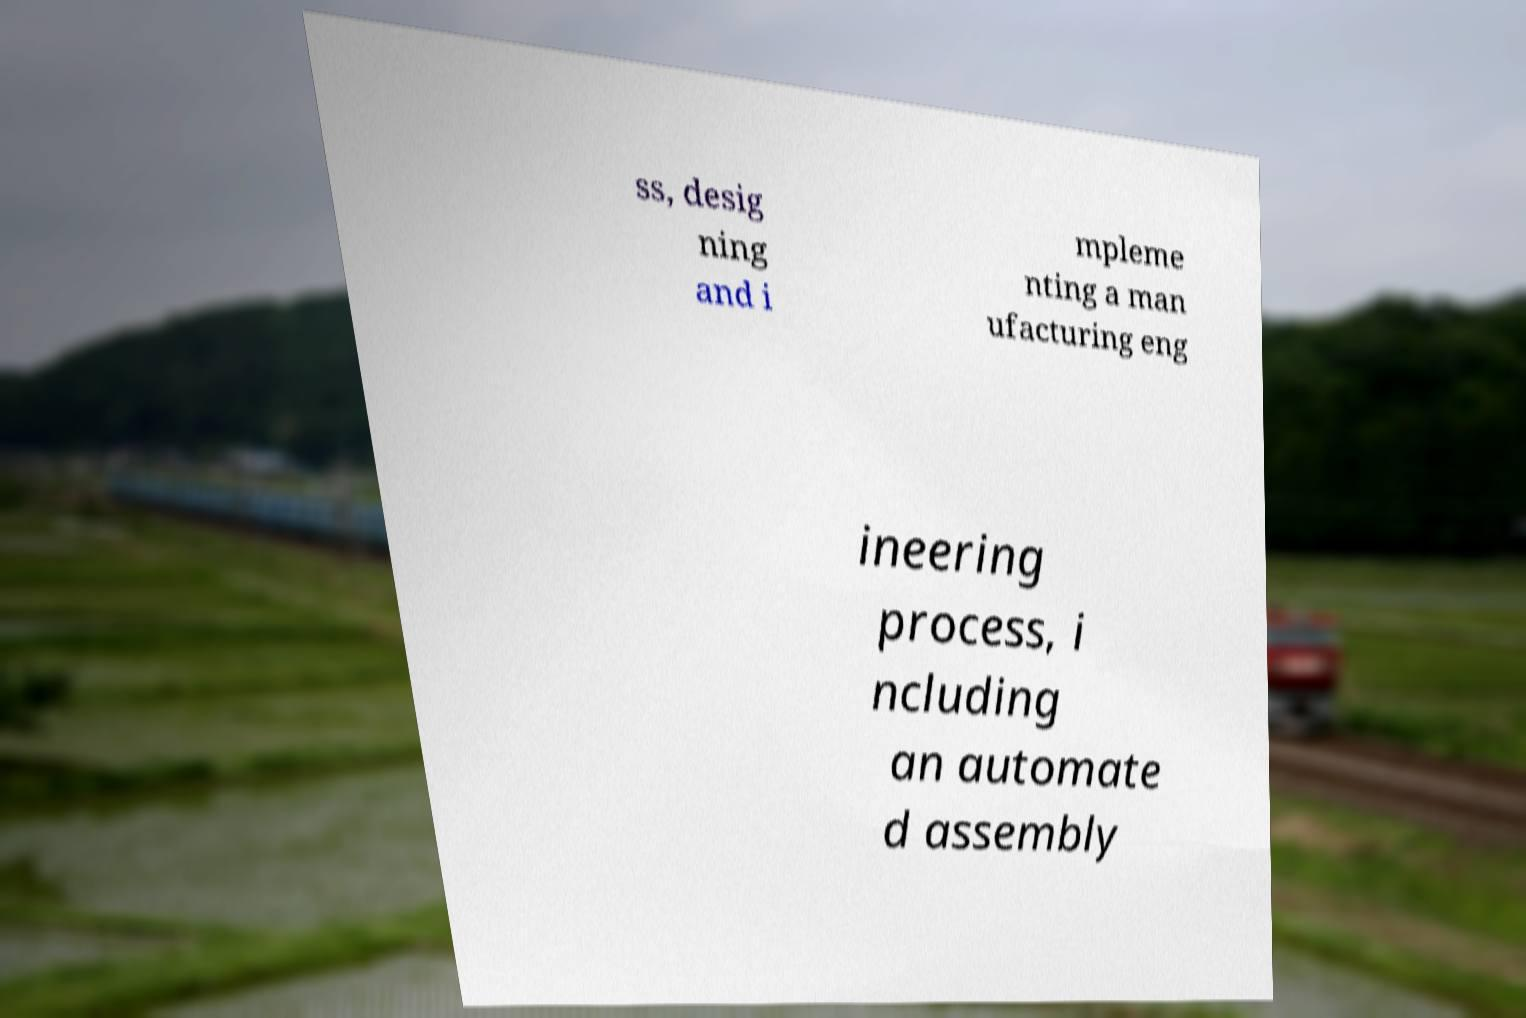There's text embedded in this image that I need extracted. Can you transcribe it verbatim? ss, desig ning and i mpleme nting a man ufacturing eng ineering process, i ncluding an automate d assembly 